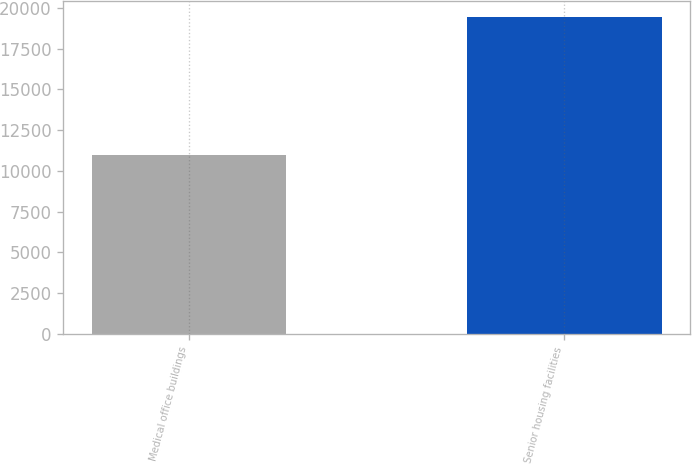Convert chart to OTSL. <chart><loc_0><loc_0><loc_500><loc_500><bar_chart><fcel>Medical office buildings<fcel>Senior housing facilities<nl><fcel>10967<fcel>19431<nl></chart> 